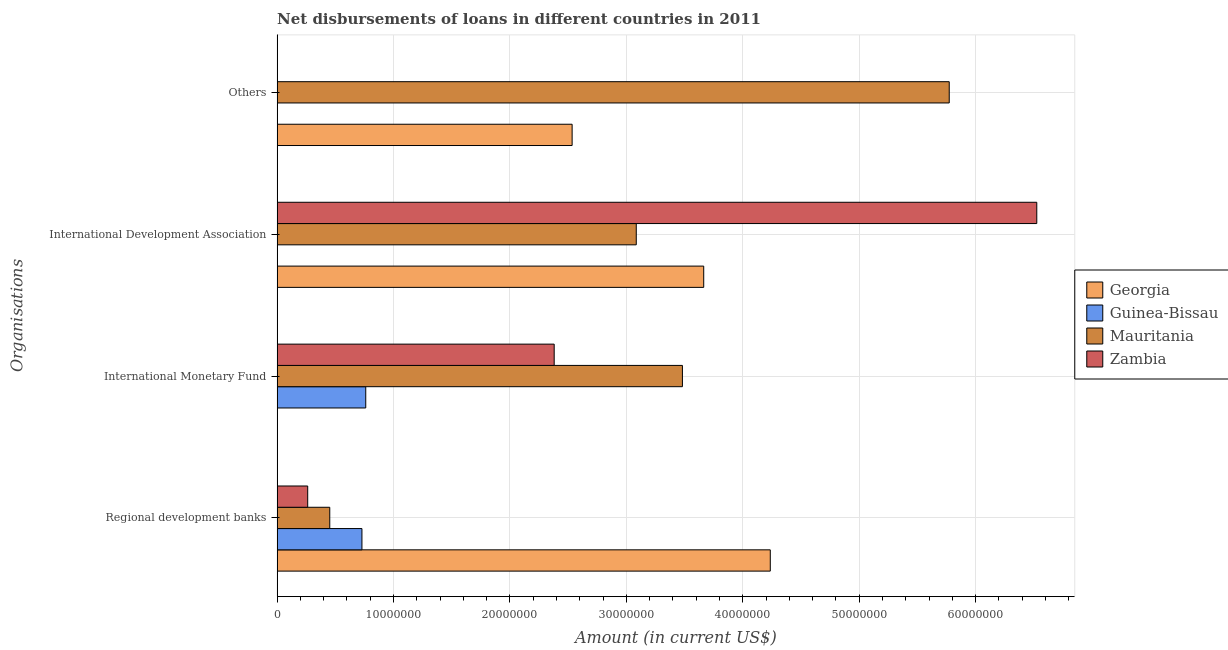How many different coloured bars are there?
Provide a short and direct response. 4. What is the label of the 3rd group of bars from the top?
Your answer should be compact. International Monetary Fund. What is the amount of loan disimbursed by international monetary fund in Mauritania?
Offer a very short reply. 3.48e+07. Across all countries, what is the maximum amount of loan disimbursed by regional development banks?
Provide a succinct answer. 4.24e+07. Across all countries, what is the minimum amount of loan disimbursed by regional development banks?
Your answer should be very brief. 2.63e+06. In which country was the amount of loan disimbursed by other organisations maximum?
Your answer should be very brief. Mauritania. What is the total amount of loan disimbursed by regional development banks in the graph?
Offer a very short reply. 5.68e+07. What is the difference between the amount of loan disimbursed by international development association in Zambia and that in Mauritania?
Your answer should be compact. 3.44e+07. What is the difference between the amount of loan disimbursed by regional development banks in Zambia and the amount of loan disimbursed by international development association in Guinea-Bissau?
Your response must be concise. 2.63e+06. What is the average amount of loan disimbursed by international development association per country?
Your response must be concise. 3.32e+07. What is the difference between the amount of loan disimbursed by international monetary fund and amount of loan disimbursed by regional development banks in Guinea-Bissau?
Provide a succinct answer. 3.28e+05. What is the ratio of the amount of loan disimbursed by regional development banks in Georgia to that in Mauritania?
Give a very brief answer. 9.37. Is the amount of loan disimbursed by other organisations in Georgia less than that in Mauritania?
Offer a terse response. Yes. What is the difference between the highest and the second highest amount of loan disimbursed by international monetary fund?
Your response must be concise. 1.10e+07. What is the difference between the highest and the lowest amount of loan disimbursed by other organisations?
Your answer should be compact. 5.77e+07. Is the sum of the amount of loan disimbursed by international monetary fund in Guinea-Bissau and Mauritania greater than the maximum amount of loan disimbursed by other organisations across all countries?
Keep it short and to the point. No. Is it the case that in every country, the sum of the amount of loan disimbursed by other organisations and amount of loan disimbursed by international development association is greater than the sum of amount of loan disimbursed by regional development banks and amount of loan disimbursed by international monetary fund?
Your response must be concise. No. Is it the case that in every country, the sum of the amount of loan disimbursed by regional development banks and amount of loan disimbursed by international monetary fund is greater than the amount of loan disimbursed by international development association?
Offer a terse response. No. How many countries are there in the graph?
Provide a short and direct response. 4. What is the difference between two consecutive major ticks on the X-axis?
Your answer should be very brief. 1.00e+07. Are the values on the major ticks of X-axis written in scientific E-notation?
Your answer should be very brief. No. Does the graph contain any zero values?
Provide a short and direct response. Yes. Does the graph contain grids?
Provide a short and direct response. Yes. What is the title of the graph?
Your response must be concise. Net disbursements of loans in different countries in 2011. Does "Korea (Republic)" appear as one of the legend labels in the graph?
Give a very brief answer. No. What is the label or title of the Y-axis?
Offer a very short reply. Organisations. What is the Amount (in current US$) of Georgia in Regional development banks?
Give a very brief answer. 4.24e+07. What is the Amount (in current US$) in Guinea-Bissau in Regional development banks?
Give a very brief answer. 7.28e+06. What is the Amount (in current US$) in Mauritania in Regional development banks?
Make the answer very short. 4.52e+06. What is the Amount (in current US$) in Zambia in Regional development banks?
Your response must be concise. 2.63e+06. What is the Amount (in current US$) of Georgia in International Monetary Fund?
Give a very brief answer. 0. What is the Amount (in current US$) of Guinea-Bissau in International Monetary Fund?
Keep it short and to the point. 7.61e+06. What is the Amount (in current US$) in Mauritania in International Monetary Fund?
Your answer should be very brief. 3.48e+07. What is the Amount (in current US$) in Zambia in International Monetary Fund?
Your answer should be compact. 2.38e+07. What is the Amount (in current US$) in Georgia in International Development Association?
Provide a succinct answer. 3.66e+07. What is the Amount (in current US$) in Mauritania in International Development Association?
Your response must be concise. 3.08e+07. What is the Amount (in current US$) of Zambia in International Development Association?
Offer a terse response. 6.53e+07. What is the Amount (in current US$) of Georgia in Others?
Your answer should be compact. 2.53e+07. What is the Amount (in current US$) in Guinea-Bissau in Others?
Offer a terse response. 0. What is the Amount (in current US$) of Mauritania in Others?
Offer a very short reply. 5.77e+07. What is the Amount (in current US$) in Zambia in Others?
Make the answer very short. 0. Across all Organisations, what is the maximum Amount (in current US$) of Georgia?
Give a very brief answer. 4.24e+07. Across all Organisations, what is the maximum Amount (in current US$) of Guinea-Bissau?
Offer a very short reply. 7.61e+06. Across all Organisations, what is the maximum Amount (in current US$) in Mauritania?
Give a very brief answer. 5.77e+07. Across all Organisations, what is the maximum Amount (in current US$) of Zambia?
Ensure brevity in your answer.  6.53e+07. Across all Organisations, what is the minimum Amount (in current US$) in Georgia?
Provide a short and direct response. 0. Across all Organisations, what is the minimum Amount (in current US$) of Mauritania?
Keep it short and to the point. 4.52e+06. Across all Organisations, what is the minimum Amount (in current US$) of Zambia?
Your response must be concise. 0. What is the total Amount (in current US$) in Georgia in the graph?
Provide a succinct answer. 1.04e+08. What is the total Amount (in current US$) of Guinea-Bissau in the graph?
Give a very brief answer. 1.49e+07. What is the total Amount (in current US$) in Mauritania in the graph?
Provide a short and direct response. 1.28e+08. What is the total Amount (in current US$) of Zambia in the graph?
Offer a terse response. 9.17e+07. What is the difference between the Amount (in current US$) of Guinea-Bissau in Regional development banks and that in International Monetary Fund?
Your answer should be very brief. -3.28e+05. What is the difference between the Amount (in current US$) in Mauritania in Regional development banks and that in International Monetary Fund?
Keep it short and to the point. -3.03e+07. What is the difference between the Amount (in current US$) in Zambia in Regional development banks and that in International Monetary Fund?
Provide a short and direct response. -2.12e+07. What is the difference between the Amount (in current US$) in Georgia in Regional development banks and that in International Development Association?
Provide a short and direct response. 5.72e+06. What is the difference between the Amount (in current US$) of Mauritania in Regional development banks and that in International Development Association?
Your answer should be very brief. -2.63e+07. What is the difference between the Amount (in current US$) of Zambia in Regional development banks and that in International Development Association?
Provide a short and direct response. -6.26e+07. What is the difference between the Amount (in current US$) of Georgia in Regional development banks and that in Others?
Provide a succinct answer. 1.70e+07. What is the difference between the Amount (in current US$) of Mauritania in Regional development banks and that in Others?
Provide a succinct answer. -5.32e+07. What is the difference between the Amount (in current US$) in Mauritania in International Monetary Fund and that in International Development Association?
Give a very brief answer. 3.96e+06. What is the difference between the Amount (in current US$) in Zambia in International Monetary Fund and that in International Development Association?
Keep it short and to the point. -4.15e+07. What is the difference between the Amount (in current US$) of Mauritania in International Monetary Fund and that in Others?
Your answer should be very brief. -2.29e+07. What is the difference between the Amount (in current US$) of Georgia in International Development Association and that in Others?
Give a very brief answer. 1.13e+07. What is the difference between the Amount (in current US$) in Mauritania in International Development Association and that in Others?
Provide a short and direct response. -2.69e+07. What is the difference between the Amount (in current US$) in Georgia in Regional development banks and the Amount (in current US$) in Guinea-Bissau in International Monetary Fund?
Provide a succinct answer. 3.47e+07. What is the difference between the Amount (in current US$) of Georgia in Regional development banks and the Amount (in current US$) of Mauritania in International Monetary Fund?
Give a very brief answer. 7.55e+06. What is the difference between the Amount (in current US$) of Georgia in Regional development banks and the Amount (in current US$) of Zambia in International Monetary Fund?
Provide a short and direct response. 1.86e+07. What is the difference between the Amount (in current US$) in Guinea-Bissau in Regional development banks and the Amount (in current US$) in Mauritania in International Monetary Fund?
Your response must be concise. -2.75e+07. What is the difference between the Amount (in current US$) in Guinea-Bissau in Regional development banks and the Amount (in current US$) in Zambia in International Monetary Fund?
Make the answer very short. -1.65e+07. What is the difference between the Amount (in current US$) in Mauritania in Regional development banks and the Amount (in current US$) in Zambia in International Monetary Fund?
Provide a short and direct response. -1.93e+07. What is the difference between the Amount (in current US$) of Georgia in Regional development banks and the Amount (in current US$) of Mauritania in International Development Association?
Give a very brief answer. 1.15e+07. What is the difference between the Amount (in current US$) of Georgia in Regional development banks and the Amount (in current US$) of Zambia in International Development Association?
Give a very brief answer. -2.29e+07. What is the difference between the Amount (in current US$) in Guinea-Bissau in Regional development banks and the Amount (in current US$) in Mauritania in International Development Association?
Make the answer very short. -2.36e+07. What is the difference between the Amount (in current US$) of Guinea-Bissau in Regional development banks and the Amount (in current US$) of Zambia in International Development Association?
Ensure brevity in your answer.  -5.80e+07. What is the difference between the Amount (in current US$) of Mauritania in Regional development banks and the Amount (in current US$) of Zambia in International Development Association?
Provide a succinct answer. -6.07e+07. What is the difference between the Amount (in current US$) of Georgia in Regional development banks and the Amount (in current US$) of Mauritania in Others?
Ensure brevity in your answer.  -1.54e+07. What is the difference between the Amount (in current US$) of Guinea-Bissau in Regional development banks and the Amount (in current US$) of Mauritania in Others?
Give a very brief answer. -5.04e+07. What is the difference between the Amount (in current US$) in Guinea-Bissau in International Monetary Fund and the Amount (in current US$) in Mauritania in International Development Association?
Keep it short and to the point. -2.32e+07. What is the difference between the Amount (in current US$) of Guinea-Bissau in International Monetary Fund and the Amount (in current US$) of Zambia in International Development Association?
Your answer should be compact. -5.76e+07. What is the difference between the Amount (in current US$) in Mauritania in International Monetary Fund and the Amount (in current US$) in Zambia in International Development Association?
Ensure brevity in your answer.  -3.04e+07. What is the difference between the Amount (in current US$) in Guinea-Bissau in International Monetary Fund and the Amount (in current US$) in Mauritania in Others?
Offer a very short reply. -5.01e+07. What is the difference between the Amount (in current US$) in Georgia in International Development Association and the Amount (in current US$) in Mauritania in Others?
Offer a terse response. -2.11e+07. What is the average Amount (in current US$) of Georgia per Organisations?
Your response must be concise. 2.61e+07. What is the average Amount (in current US$) of Guinea-Bissau per Organisations?
Offer a terse response. 3.72e+06. What is the average Amount (in current US$) in Mauritania per Organisations?
Make the answer very short. 3.20e+07. What is the average Amount (in current US$) in Zambia per Organisations?
Make the answer very short. 2.29e+07. What is the difference between the Amount (in current US$) of Georgia and Amount (in current US$) of Guinea-Bissau in Regional development banks?
Your answer should be compact. 3.51e+07. What is the difference between the Amount (in current US$) in Georgia and Amount (in current US$) in Mauritania in Regional development banks?
Make the answer very short. 3.78e+07. What is the difference between the Amount (in current US$) in Georgia and Amount (in current US$) in Zambia in Regional development banks?
Your answer should be very brief. 3.97e+07. What is the difference between the Amount (in current US$) of Guinea-Bissau and Amount (in current US$) of Mauritania in Regional development banks?
Offer a terse response. 2.76e+06. What is the difference between the Amount (in current US$) of Guinea-Bissau and Amount (in current US$) of Zambia in Regional development banks?
Provide a short and direct response. 4.66e+06. What is the difference between the Amount (in current US$) of Mauritania and Amount (in current US$) of Zambia in Regional development banks?
Keep it short and to the point. 1.90e+06. What is the difference between the Amount (in current US$) of Guinea-Bissau and Amount (in current US$) of Mauritania in International Monetary Fund?
Give a very brief answer. -2.72e+07. What is the difference between the Amount (in current US$) in Guinea-Bissau and Amount (in current US$) in Zambia in International Monetary Fund?
Keep it short and to the point. -1.62e+07. What is the difference between the Amount (in current US$) in Mauritania and Amount (in current US$) in Zambia in International Monetary Fund?
Provide a short and direct response. 1.10e+07. What is the difference between the Amount (in current US$) in Georgia and Amount (in current US$) in Mauritania in International Development Association?
Provide a short and direct response. 5.80e+06. What is the difference between the Amount (in current US$) of Georgia and Amount (in current US$) of Zambia in International Development Association?
Ensure brevity in your answer.  -2.86e+07. What is the difference between the Amount (in current US$) in Mauritania and Amount (in current US$) in Zambia in International Development Association?
Ensure brevity in your answer.  -3.44e+07. What is the difference between the Amount (in current US$) of Georgia and Amount (in current US$) of Mauritania in Others?
Offer a terse response. -3.24e+07. What is the ratio of the Amount (in current US$) of Guinea-Bissau in Regional development banks to that in International Monetary Fund?
Offer a terse response. 0.96. What is the ratio of the Amount (in current US$) in Mauritania in Regional development banks to that in International Monetary Fund?
Your answer should be very brief. 0.13. What is the ratio of the Amount (in current US$) in Zambia in Regional development banks to that in International Monetary Fund?
Your answer should be compact. 0.11. What is the ratio of the Amount (in current US$) in Georgia in Regional development banks to that in International Development Association?
Make the answer very short. 1.16. What is the ratio of the Amount (in current US$) in Mauritania in Regional development banks to that in International Development Association?
Your answer should be compact. 0.15. What is the ratio of the Amount (in current US$) in Zambia in Regional development banks to that in International Development Association?
Make the answer very short. 0.04. What is the ratio of the Amount (in current US$) of Georgia in Regional development banks to that in Others?
Make the answer very short. 1.67. What is the ratio of the Amount (in current US$) in Mauritania in Regional development banks to that in Others?
Your answer should be compact. 0.08. What is the ratio of the Amount (in current US$) in Mauritania in International Monetary Fund to that in International Development Association?
Provide a short and direct response. 1.13. What is the ratio of the Amount (in current US$) in Zambia in International Monetary Fund to that in International Development Association?
Provide a succinct answer. 0.36. What is the ratio of the Amount (in current US$) of Mauritania in International Monetary Fund to that in Others?
Give a very brief answer. 0.6. What is the ratio of the Amount (in current US$) in Georgia in International Development Association to that in Others?
Offer a very short reply. 1.45. What is the ratio of the Amount (in current US$) of Mauritania in International Development Association to that in Others?
Provide a short and direct response. 0.53. What is the difference between the highest and the second highest Amount (in current US$) in Georgia?
Ensure brevity in your answer.  5.72e+06. What is the difference between the highest and the second highest Amount (in current US$) of Mauritania?
Your answer should be very brief. 2.29e+07. What is the difference between the highest and the second highest Amount (in current US$) in Zambia?
Provide a succinct answer. 4.15e+07. What is the difference between the highest and the lowest Amount (in current US$) of Georgia?
Keep it short and to the point. 4.24e+07. What is the difference between the highest and the lowest Amount (in current US$) in Guinea-Bissau?
Provide a succinct answer. 7.61e+06. What is the difference between the highest and the lowest Amount (in current US$) in Mauritania?
Make the answer very short. 5.32e+07. What is the difference between the highest and the lowest Amount (in current US$) of Zambia?
Offer a very short reply. 6.53e+07. 